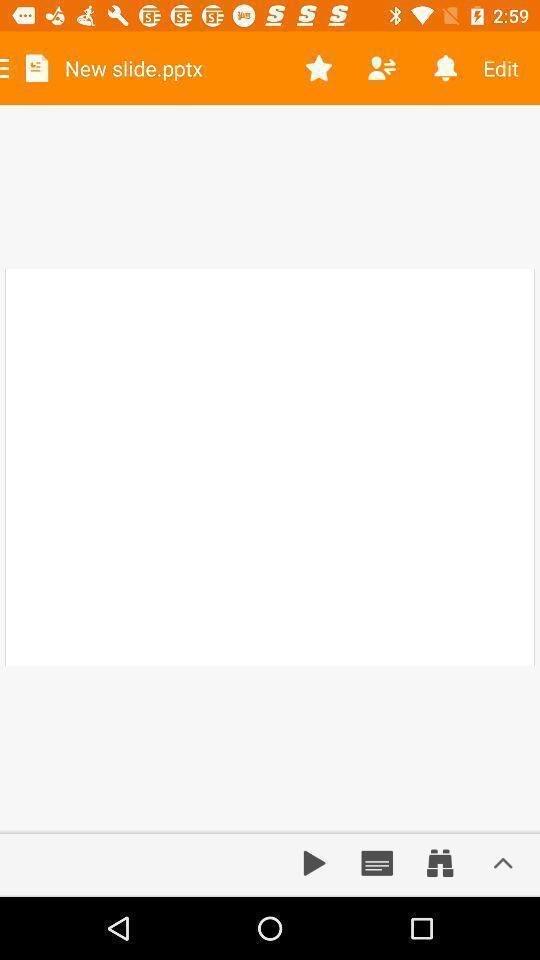Explain what's happening in this screen capture. Screen showing new slide. 